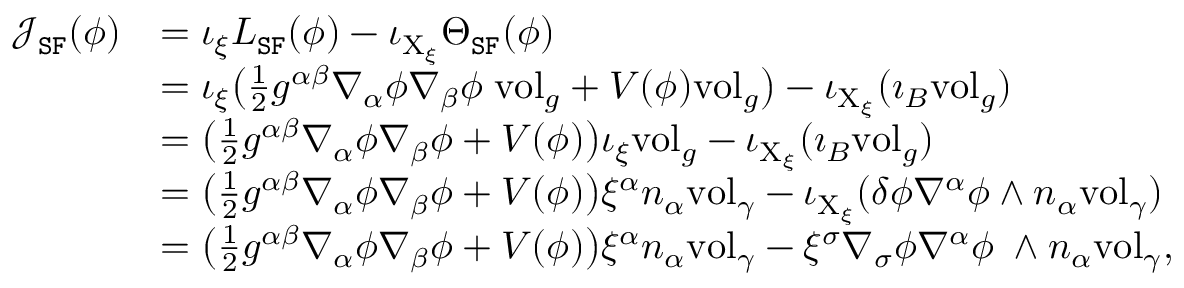<formula> <loc_0><loc_0><loc_500><loc_500>\begin{array} { r l } { \mathcal { J } _ { S F } ( \phi ) } & { = \iota _ { \xi } L _ { S F } ( \phi ) - \iota _ { X _ { \xi } } \Theta _ { S F } ( \phi ) } \\ & { = \iota _ { \xi } \left ( \frac { 1 } { 2 } g ^ { \alpha \beta } \nabla _ { \alpha } \phi \nabla _ { \beta } \phi \, v o l _ { g } + V ( \phi ) v o l _ { g } \right ) - \iota _ { X _ { \xi } } ( \imath _ { B } v o l _ { g } ) } \\ & { = \left ( \frac { 1 } { 2 } g ^ { \alpha \beta } \nabla _ { \alpha } \phi \nabla _ { \beta } \phi + V ( \phi ) \right ) \iota _ { \xi } v o l _ { g } - \iota _ { X _ { \xi } } ( \imath _ { B } v o l _ { g } ) } \\ & { = \left ( \frac { 1 } { 2 } g ^ { \alpha \beta } \nabla _ { \alpha } \phi \nabla _ { \beta } \phi + V ( \phi ) \right ) \xi ^ { \alpha } n _ { \alpha } v o l _ { \gamma } - \iota _ { X _ { \xi } } ( \delta \phi \nabla ^ { \alpha } \phi \wedge n _ { \alpha } v o l _ { \gamma } ) } \\ & { = \left ( \frac { 1 } { 2 } g ^ { \alpha \beta } \nabla _ { \alpha } \phi \nabla _ { \beta } \phi + V ( \phi ) \right ) \xi ^ { \alpha } n _ { \alpha } v o l _ { \gamma } - \xi ^ { \sigma } \nabla _ { \sigma } \phi \nabla ^ { \alpha } \phi \, \wedge n _ { \alpha } v o l _ { \gamma } , } \end{array}</formula> 